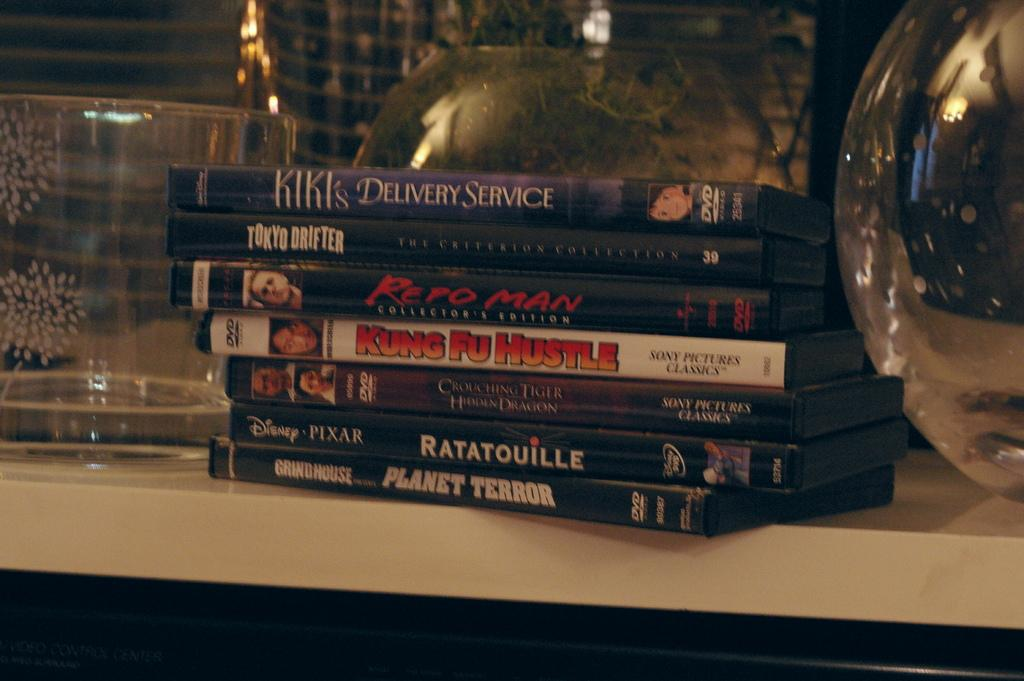<image>
Describe the image concisely. Kiki's Delivery Service DVD on top of other DVDs. 